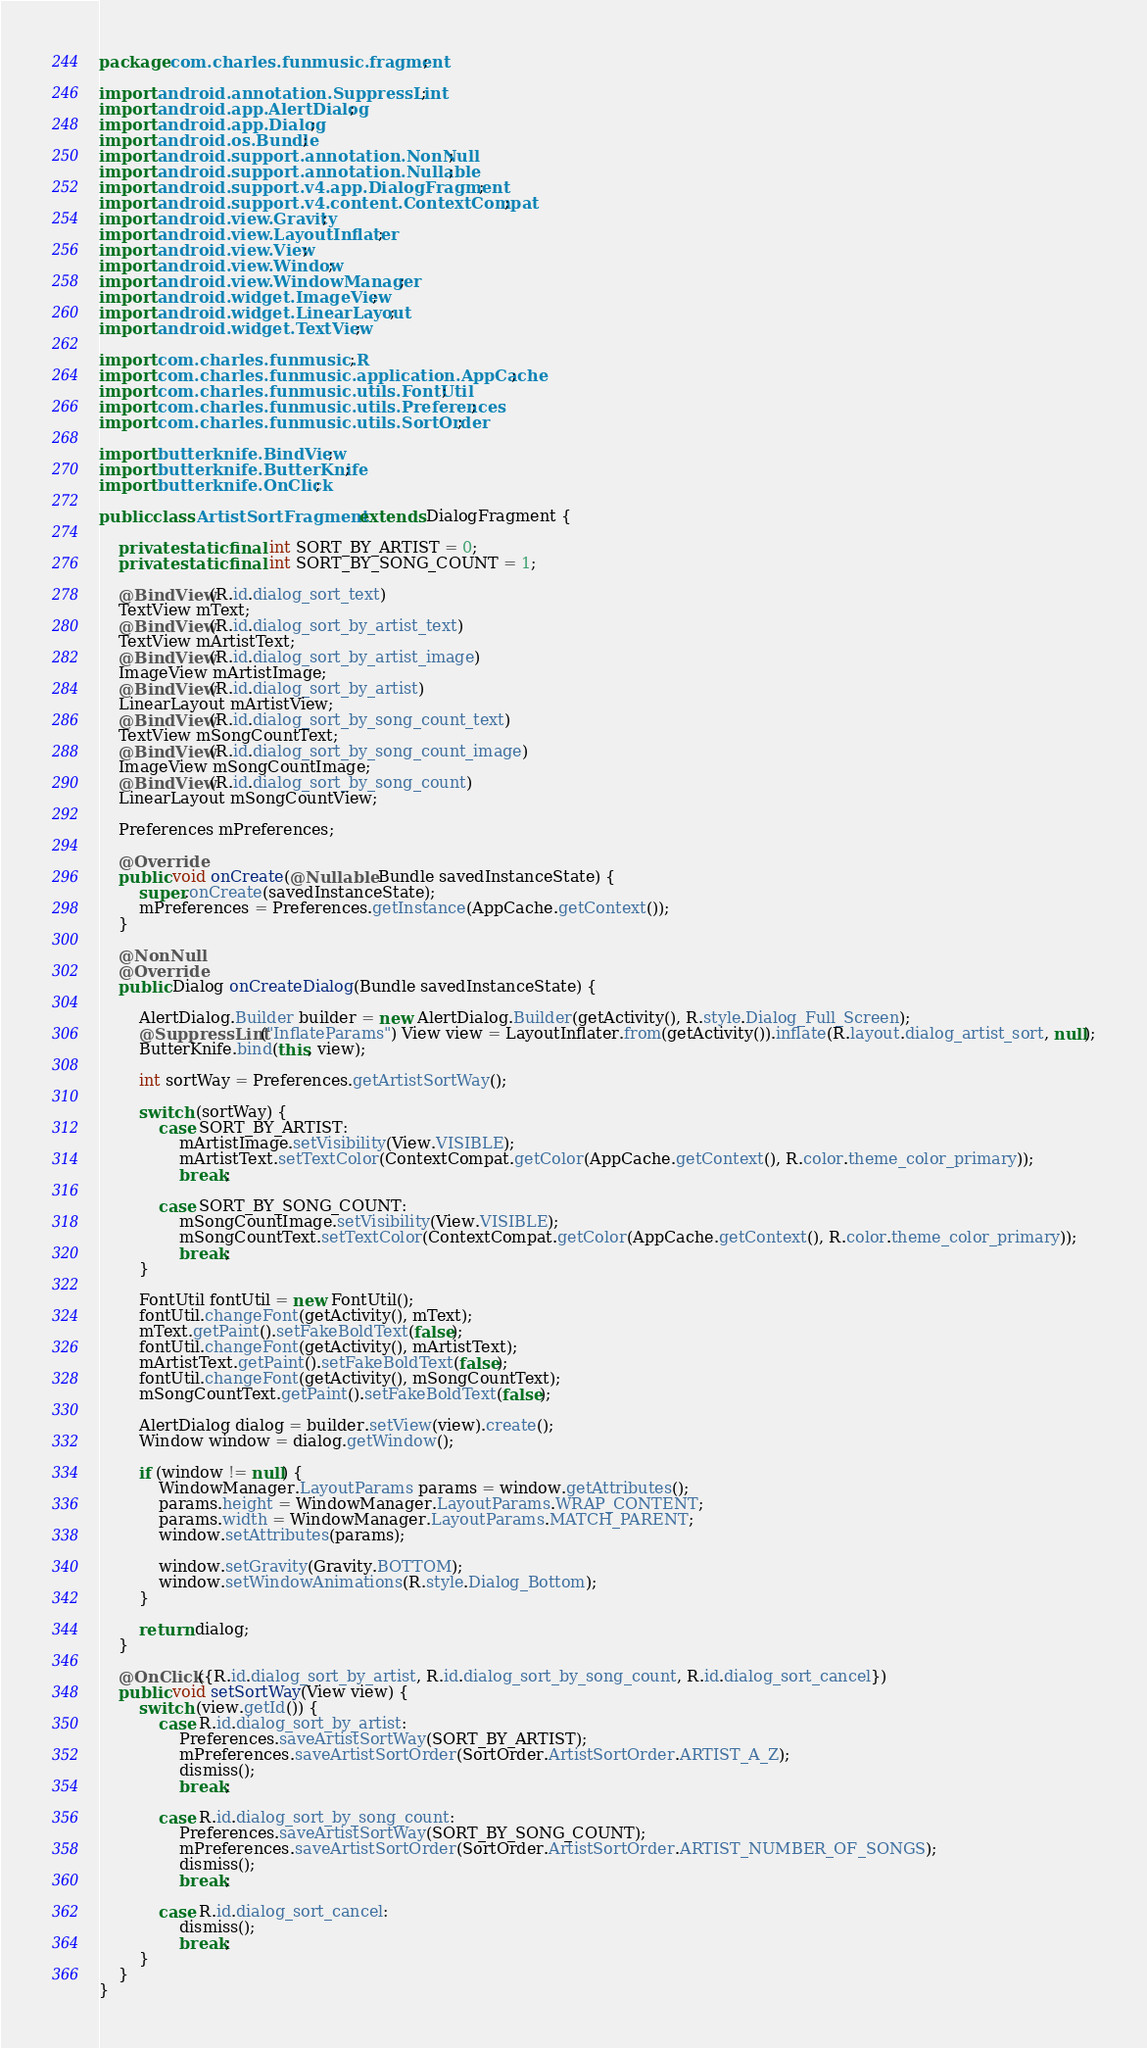Convert code to text. <code><loc_0><loc_0><loc_500><loc_500><_Java_>package com.charles.funmusic.fragment;

import android.annotation.SuppressLint;
import android.app.AlertDialog;
import android.app.Dialog;
import android.os.Bundle;
import android.support.annotation.NonNull;
import android.support.annotation.Nullable;
import android.support.v4.app.DialogFragment;
import android.support.v4.content.ContextCompat;
import android.view.Gravity;
import android.view.LayoutInflater;
import android.view.View;
import android.view.Window;
import android.view.WindowManager;
import android.widget.ImageView;
import android.widget.LinearLayout;
import android.widget.TextView;

import com.charles.funmusic.R;
import com.charles.funmusic.application.AppCache;
import com.charles.funmusic.utils.FontUtil;
import com.charles.funmusic.utils.Preferences;
import com.charles.funmusic.utils.SortOrder;

import butterknife.BindView;
import butterknife.ButterKnife;
import butterknife.OnClick;

public class ArtistSortFragment extends DialogFragment {

    private static final int SORT_BY_ARTIST = 0;
    private static final int SORT_BY_SONG_COUNT = 1;

    @BindView(R.id.dialog_sort_text)
    TextView mText;
    @BindView(R.id.dialog_sort_by_artist_text)
    TextView mArtistText;
    @BindView(R.id.dialog_sort_by_artist_image)
    ImageView mArtistImage;
    @BindView(R.id.dialog_sort_by_artist)
    LinearLayout mArtistView;
    @BindView(R.id.dialog_sort_by_song_count_text)
    TextView mSongCountText;
    @BindView(R.id.dialog_sort_by_song_count_image)
    ImageView mSongCountImage;
    @BindView(R.id.dialog_sort_by_song_count)
    LinearLayout mSongCountView;

    Preferences mPreferences;

    @Override
    public void onCreate(@Nullable Bundle savedInstanceState) {
        super.onCreate(savedInstanceState);
        mPreferences = Preferences.getInstance(AppCache.getContext());
    }

    @NonNull
    @Override
    public Dialog onCreateDialog(Bundle savedInstanceState) {

        AlertDialog.Builder builder = new AlertDialog.Builder(getActivity(), R.style.Dialog_Full_Screen);
        @SuppressLint("InflateParams") View view = LayoutInflater.from(getActivity()).inflate(R.layout.dialog_artist_sort, null);
        ButterKnife.bind(this, view);

        int sortWay = Preferences.getArtistSortWay();

        switch (sortWay) {
            case SORT_BY_ARTIST:
                mArtistImage.setVisibility(View.VISIBLE);
                mArtistText.setTextColor(ContextCompat.getColor(AppCache.getContext(), R.color.theme_color_primary));
                break;

            case SORT_BY_SONG_COUNT:
                mSongCountImage.setVisibility(View.VISIBLE);
                mSongCountText.setTextColor(ContextCompat.getColor(AppCache.getContext(), R.color.theme_color_primary));
                break;
        }

        FontUtil fontUtil = new FontUtil();
        fontUtil.changeFont(getActivity(), mText);
        mText.getPaint().setFakeBoldText(false);
        fontUtil.changeFont(getActivity(), mArtistText);
        mArtistText.getPaint().setFakeBoldText(false);
        fontUtil.changeFont(getActivity(), mSongCountText);
        mSongCountText.getPaint().setFakeBoldText(false);

        AlertDialog dialog = builder.setView(view).create();
        Window window = dialog.getWindow();

        if (window != null) {
            WindowManager.LayoutParams params = window.getAttributes();
            params.height = WindowManager.LayoutParams.WRAP_CONTENT;
            params.width = WindowManager.LayoutParams.MATCH_PARENT;
            window.setAttributes(params);

            window.setGravity(Gravity.BOTTOM);
            window.setWindowAnimations(R.style.Dialog_Bottom);
        }

        return dialog;
    }

    @OnClick({R.id.dialog_sort_by_artist, R.id.dialog_sort_by_song_count, R.id.dialog_sort_cancel})
    public void setSortWay(View view) {
        switch (view.getId()) {
            case R.id.dialog_sort_by_artist:
                Preferences.saveArtistSortWay(SORT_BY_ARTIST);
                mPreferences.saveArtistSortOrder(SortOrder.ArtistSortOrder.ARTIST_A_Z);
                dismiss();
                break;

            case R.id.dialog_sort_by_song_count:
                Preferences.saveArtistSortWay(SORT_BY_SONG_COUNT);
                mPreferences.saveArtistSortOrder(SortOrder.ArtistSortOrder.ARTIST_NUMBER_OF_SONGS);
                dismiss();
                break;

            case R.id.dialog_sort_cancel:
                dismiss();
                break;
        }
    }
}
</code> 